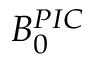Convert formula to latex. <formula><loc_0><loc_0><loc_500><loc_500>B _ { 0 } ^ { P I C }</formula> 